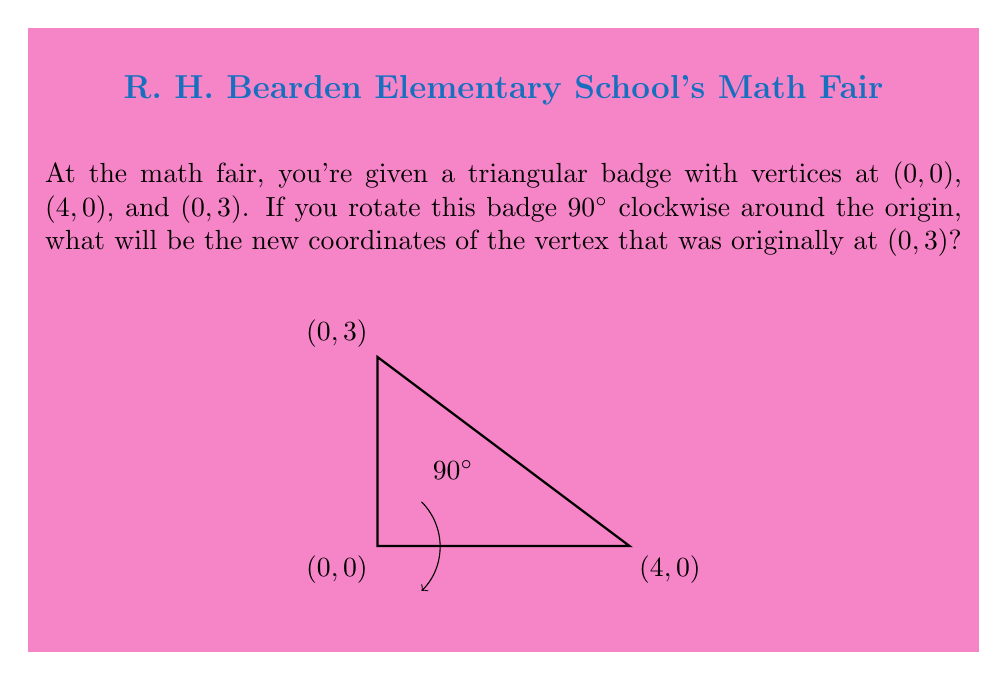What is the answer to this math problem? Let's approach this step-by-step:

1) A 90° clockwise rotation around the origin transforms a point (x,y) to (y,-x).

2) We need to apply this transformation to the point (0,3):
   $$(x,y) = (0,3)$$

3) After rotation:
   $$x_{new} = y = 3$$
   $$y_{new} = -x = -(0) = 0$$

4) Therefore, the new coordinates are (3,0).

To visualize:

[asy]
unitsize(1cm);
draw((0,0)--(4,0)--(0,3)--cycle, gray);
draw((0,0)--(0,-4)--(3,0)--cycle, black);
label("(0,0)", (0,0), SW);
label("(4,0)", (4,0), SE);
label("(0,3)", (0,3), NW);
label("(3,0)", (3,0), NE);
label("(0,-4)", (0,-4), SW);
draw(arc((0,0), 1, 0, -90), arrow=Arrow(TeXHead));
label("90°", (0.7,0.7), NE);
[/asy]

The original triangle is shown in gray, and the rotated triangle in black.
Answer: (3,0) 